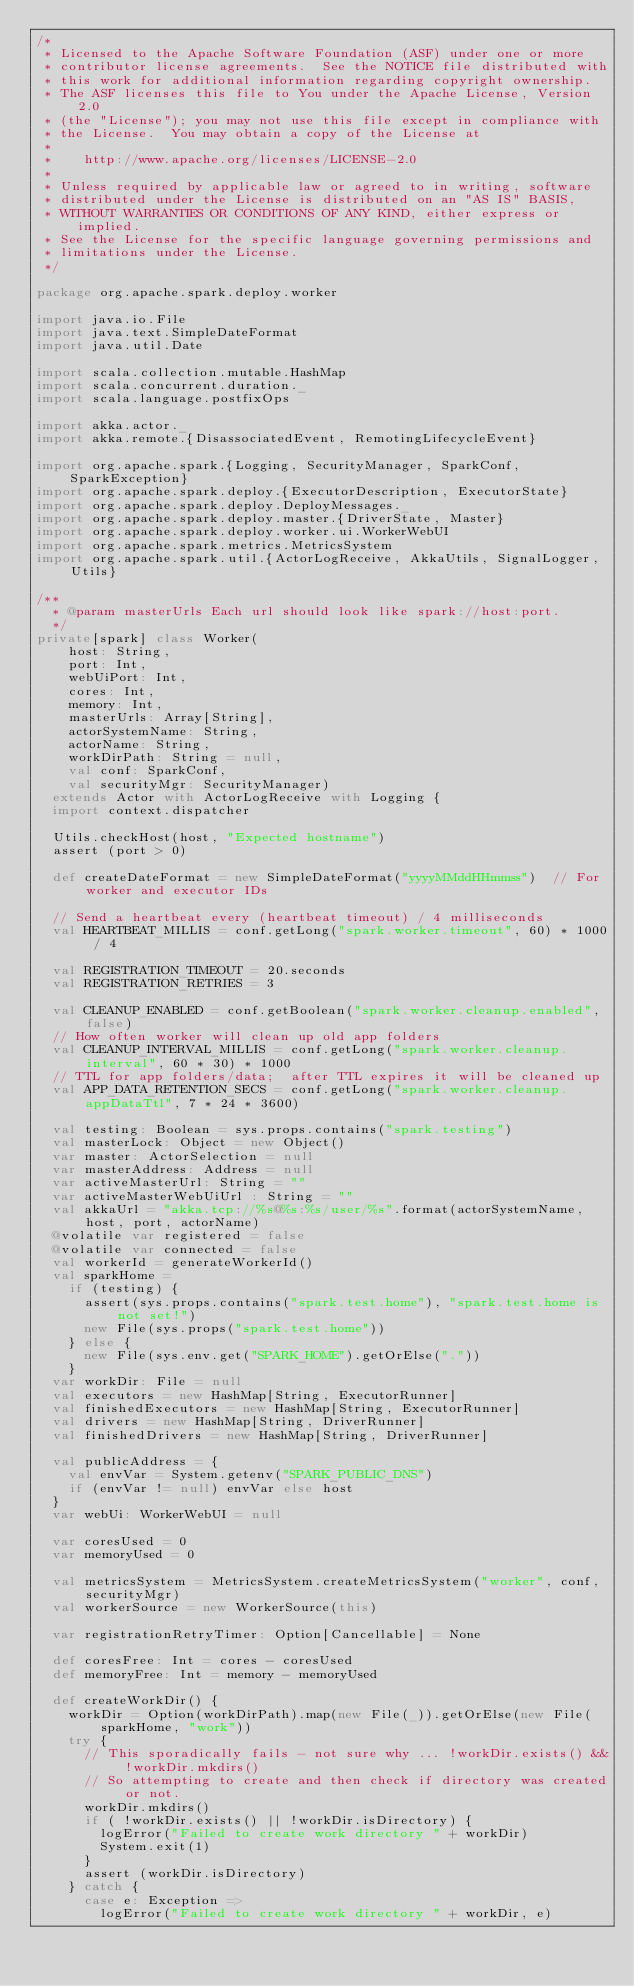<code> <loc_0><loc_0><loc_500><loc_500><_Scala_>/*
 * Licensed to the Apache Software Foundation (ASF) under one or more
 * contributor license agreements.  See the NOTICE file distributed with
 * this work for additional information regarding copyright ownership.
 * The ASF licenses this file to You under the Apache License, Version 2.0
 * (the "License"); you may not use this file except in compliance with
 * the License.  You may obtain a copy of the License at
 *
 *    http://www.apache.org/licenses/LICENSE-2.0
 *
 * Unless required by applicable law or agreed to in writing, software
 * distributed under the License is distributed on an "AS IS" BASIS,
 * WITHOUT WARRANTIES OR CONDITIONS OF ANY KIND, either express or implied.
 * See the License for the specific language governing permissions and
 * limitations under the License.
 */

package org.apache.spark.deploy.worker

import java.io.File
import java.text.SimpleDateFormat
import java.util.Date

import scala.collection.mutable.HashMap
import scala.concurrent.duration._
import scala.language.postfixOps

import akka.actor._
import akka.remote.{DisassociatedEvent, RemotingLifecycleEvent}

import org.apache.spark.{Logging, SecurityManager, SparkConf, SparkException}
import org.apache.spark.deploy.{ExecutorDescription, ExecutorState}
import org.apache.spark.deploy.DeployMessages._
import org.apache.spark.deploy.master.{DriverState, Master}
import org.apache.spark.deploy.worker.ui.WorkerWebUI
import org.apache.spark.metrics.MetricsSystem
import org.apache.spark.util.{ActorLogReceive, AkkaUtils, SignalLogger, Utils}

/**
  * @param masterUrls Each url should look like spark://host:port.
  */
private[spark] class Worker(
    host: String,
    port: Int,
    webUiPort: Int,
    cores: Int,
    memory: Int,
    masterUrls: Array[String],
    actorSystemName: String,
    actorName: String,
    workDirPath: String = null,
    val conf: SparkConf,
    val securityMgr: SecurityManager)
  extends Actor with ActorLogReceive with Logging {
  import context.dispatcher

  Utils.checkHost(host, "Expected hostname")
  assert (port > 0)

  def createDateFormat = new SimpleDateFormat("yyyyMMddHHmmss")  // For worker and executor IDs

  // Send a heartbeat every (heartbeat timeout) / 4 milliseconds
  val HEARTBEAT_MILLIS = conf.getLong("spark.worker.timeout", 60) * 1000 / 4

  val REGISTRATION_TIMEOUT = 20.seconds
  val REGISTRATION_RETRIES = 3

  val CLEANUP_ENABLED = conf.getBoolean("spark.worker.cleanup.enabled", false)
  // How often worker will clean up old app folders
  val CLEANUP_INTERVAL_MILLIS = conf.getLong("spark.worker.cleanup.interval", 60 * 30) * 1000
  // TTL for app folders/data;  after TTL expires it will be cleaned up
  val APP_DATA_RETENTION_SECS = conf.getLong("spark.worker.cleanup.appDataTtl", 7 * 24 * 3600)

  val testing: Boolean = sys.props.contains("spark.testing")
  val masterLock: Object = new Object()
  var master: ActorSelection = null
  var masterAddress: Address = null
  var activeMasterUrl: String = ""
  var activeMasterWebUiUrl : String = ""
  val akkaUrl = "akka.tcp://%s@%s:%s/user/%s".format(actorSystemName, host, port, actorName)
  @volatile var registered = false
  @volatile var connected = false
  val workerId = generateWorkerId()
  val sparkHome =
    if (testing) {
      assert(sys.props.contains("spark.test.home"), "spark.test.home is not set!")
      new File(sys.props("spark.test.home"))
    } else {
      new File(sys.env.get("SPARK_HOME").getOrElse("."))
    }
  var workDir: File = null
  val executors = new HashMap[String, ExecutorRunner]
  val finishedExecutors = new HashMap[String, ExecutorRunner]
  val drivers = new HashMap[String, DriverRunner]
  val finishedDrivers = new HashMap[String, DriverRunner]

  val publicAddress = {
    val envVar = System.getenv("SPARK_PUBLIC_DNS")
    if (envVar != null) envVar else host
  }
  var webUi: WorkerWebUI = null

  var coresUsed = 0
  var memoryUsed = 0

  val metricsSystem = MetricsSystem.createMetricsSystem("worker", conf, securityMgr)
  val workerSource = new WorkerSource(this)

  var registrationRetryTimer: Option[Cancellable] = None

  def coresFree: Int = cores - coresUsed
  def memoryFree: Int = memory - memoryUsed

  def createWorkDir() {
    workDir = Option(workDirPath).map(new File(_)).getOrElse(new File(sparkHome, "work"))
    try {
      // This sporadically fails - not sure why ... !workDir.exists() && !workDir.mkdirs()
      // So attempting to create and then check if directory was created or not.
      workDir.mkdirs()
      if ( !workDir.exists() || !workDir.isDirectory) {
        logError("Failed to create work directory " + workDir)
        System.exit(1)
      }
      assert (workDir.isDirectory)
    } catch {
      case e: Exception =>
        logError("Failed to create work directory " + workDir, e)</code> 